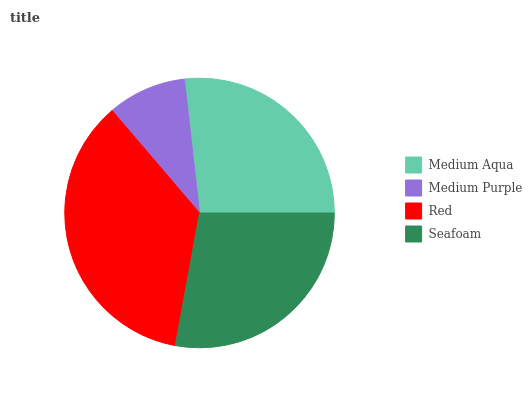Is Medium Purple the minimum?
Answer yes or no. Yes. Is Red the maximum?
Answer yes or no. Yes. Is Red the minimum?
Answer yes or no. No. Is Medium Purple the maximum?
Answer yes or no. No. Is Red greater than Medium Purple?
Answer yes or no. Yes. Is Medium Purple less than Red?
Answer yes or no. Yes. Is Medium Purple greater than Red?
Answer yes or no. No. Is Red less than Medium Purple?
Answer yes or no. No. Is Seafoam the high median?
Answer yes or no. Yes. Is Medium Aqua the low median?
Answer yes or no. Yes. Is Medium Aqua the high median?
Answer yes or no. No. Is Red the low median?
Answer yes or no. No. 